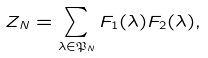Convert formula to latex. <formula><loc_0><loc_0><loc_500><loc_500>Z _ { N } = \sum _ { \lambda \in \mathfrak { P } _ { N } } F _ { 1 } ( \lambda ) F _ { 2 } ( \lambda ) ,</formula> 